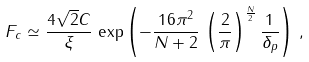Convert formula to latex. <formula><loc_0><loc_0><loc_500><loc_500>F _ { c } \simeq \frac { 4 \sqrt { 2 } C } { \xi } \, \exp \left ( - \frac { 1 6 \pi ^ { 2 } } { N + 2 } \, \left ( \frac { 2 } { \pi } \right ) ^ { \frac { N } { 2 } } \frac { 1 } { \delta _ { p } } \right ) \, ,</formula> 